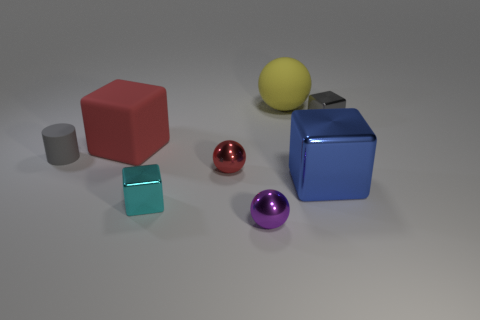There is a red object that is the same size as the purple metal thing; what is its shape?
Your response must be concise. Sphere. Is there another tiny shiny object that has the same shape as the yellow thing?
Provide a succinct answer. Yes. Does the tiny gray block have the same material as the large cube in front of the matte block?
Give a very brief answer. Yes. The tiny object that is behind the tiny thing that is on the left side of the large cube on the left side of the cyan thing is what color?
Keep it short and to the point. Gray. There is a cylinder that is the same size as the gray metallic thing; what is its material?
Offer a very short reply. Rubber. What number of big red objects have the same material as the large blue thing?
Provide a short and direct response. 0. Do the red matte block to the left of the yellow ball and the metal ball in front of the tiny cyan thing have the same size?
Keep it short and to the point. No. What is the color of the metal cube to the left of the blue metallic object?
Offer a very short reply. Cyan. What number of small objects have the same color as the small cylinder?
Your response must be concise. 1. There is a blue shiny cube; does it have the same size as the metallic sphere in front of the tiny red object?
Provide a succinct answer. No. 